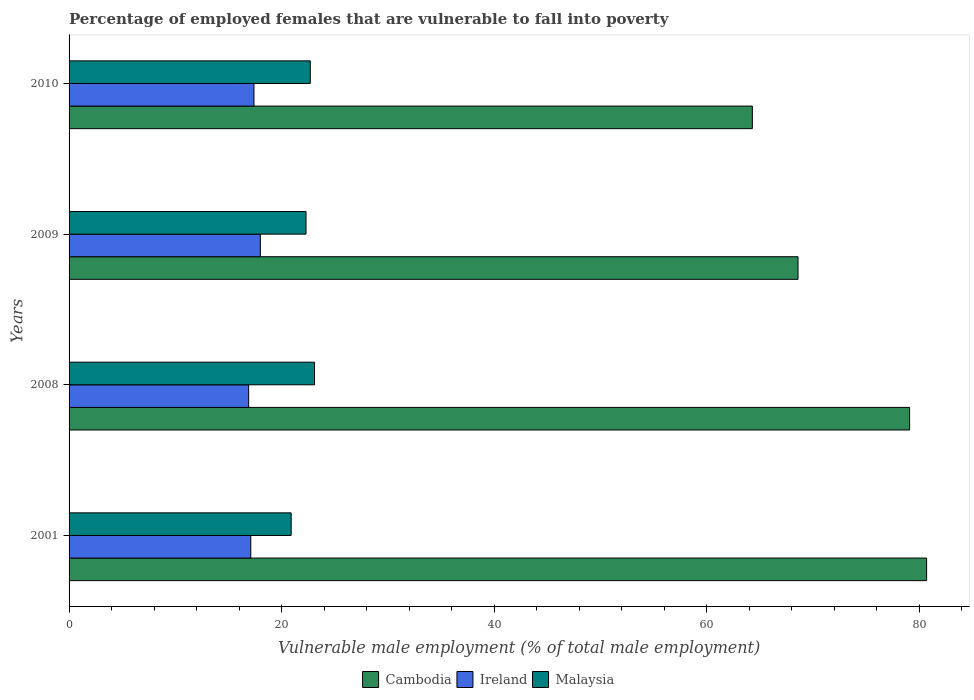Are the number of bars per tick equal to the number of legend labels?
Your answer should be very brief. Yes. Are the number of bars on each tick of the Y-axis equal?
Your answer should be compact. Yes. How many bars are there on the 2nd tick from the top?
Provide a succinct answer. 3. In how many cases, is the number of bars for a given year not equal to the number of legend labels?
Your answer should be compact. 0. What is the percentage of employed females who are vulnerable to fall into poverty in Cambodia in 2008?
Keep it short and to the point. 79.1. Across all years, what is the maximum percentage of employed females who are vulnerable to fall into poverty in Cambodia?
Give a very brief answer. 80.7. Across all years, what is the minimum percentage of employed females who are vulnerable to fall into poverty in Cambodia?
Your answer should be compact. 64.3. In which year was the percentage of employed females who are vulnerable to fall into poverty in Malaysia maximum?
Provide a short and direct response. 2008. In which year was the percentage of employed females who are vulnerable to fall into poverty in Ireland minimum?
Give a very brief answer. 2008. What is the total percentage of employed females who are vulnerable to fall into poverty in Cambodia in the graph?
Offer a terse response. 292.7. What is the difference between the percentage of employed females who are vulnerable to fall into poverty in Cambodia in 2008 and that in 2010?
Ensure brevity in your answer.  14.8. What is the difference between the percentage of employed females who are vulnerable to fall into poverty in Cambodia in 2008 and the percentage of employed females who are vulnerable to fall into poverty in Ireland in 2001?
Offer a terse response. 62. What is the average percentage of employed females who are vulnerable to fall into poverty in Ireland per year?
Provide a short and direct response. 17.35. In the year 2008, what is the difference between the percentage of employed females who are vulnerable to fall into poverty in Ireland and percentage of employed females who are vulnerable to fall into poverty in Malaysia?
Your answer should be very brief. -6.2. What is the ratio of the percentage of employed females who are vulnerable to fall into poverty in Cambodia in 2001 to that in 2010?
Ensure brevity in your answer.  1.26. Is the percentage of employed females who are vulnerable to fall into poverty in Malaysia in 2008 less than that in 2010?
Offer a very short reply. No. Is the difference between the percentage of employed females who are vulnerable to fall into poverty in Ireland in 2001 and 2008 greater than the difference between the percentage of employed females who are vulnerable to fall into poverty in Malaysia in 2001 and 2008?
Make the answer very short. Yes. What is the difference between the highest and the second highest percentage of employed females who are vulnerable to fall into poverty in Cambodia?
Your response must be concise. 1.6. What is the difference between the highest and the lowest percentage of employed females who are vulnerable to fall into poverty in Ireland?
Your answer should be very brief. 1.1. What does the 3rd bar from the top in 2008 represents?
Your response must be concise. Cambodia. What does the 2nd bar from the bottom in 2001 represents?
Your answer should be compact. Ireland. How many bars are there?
Offer a very short reply. 12. Are all the bars in the graph horizontal?
Ensure brevity in your answer.  Yes. How many years are there in the graph?
Keep it short and to the point. 4. Are the values on the major ticks of X-axis written in scientific E-notation?
Your answer should be very brief. No. Does the graph contain grids?
Offer a very short reply. No. Where does the legend appear in the graph?
Your response must be concise. Bottom center. How many legend labels are there?
Offer a very short reply. 3. What is the title of the graph?
Your response must be concise. Percentage of employed females that are vulnerable to fall into poverty. Does "Iceland" appear as one of the legend labels in the graph?
Your response must be concise. No. What is the label or title of the X-axis?
Your answer should be very brief. Vulnerable male employment (% of total male employment). What is the label or title of the Y-axis?
Provide a succinct answer. Years. What is the Vulnerable male employment (% of total male employment) of Cambodia in 2001?
Your answer should be compact. 80.7. What is the Vulnerable male employment (% of total male employment) in Ireland in 2001?
Your answer should be compact. 17.1. What is the Vulnerable male employment (% of total male employment) in Malaysia in 2001?
Your answer should be compact. 20.9. What is the Vulnerable male employment (% of total male employment) of Cambodia in 2008?
Your answer should be very brief. 79.1. What is the Vulnerable male employment (% of total male employment) in Ireland in 2008?
Offer a terse response. 16.9. What is the Vulnerable male employment (% of total male employment) of Malaysia in 2008?
Offer a terse response. 23.1. What is the Vulnerable male employment (% of total male employment) in Cambodia in 2009?
Offer a very short reply. 68.6. What is the Vulnerable male employment (% of total male employment) in Ireland in 2009?
Offer a terse response. 18. What is the Vulnerable male employment (% of total male employment) in Malaysia in 2009?
Offer a very short reply. 22.3. What is the Vulnerable male employment (% of total male employment) in Cambodia in 2010?
Your response must be concise. 64.3. What is the Vulnerable male employment (% of total male employment) in Ireland in 2010?
Offer a terse response. 17.4. What is the Vulnerable male employment (% of total male employment) of Malaysia in 2010?
Make the answer very short. 22.7. Across all years, what is the maximum Vulnerable male employment (% of total male employment) of Cambodia?
Keep it short and to the point. 80.7. Across all years, what is the maximum Vulnerable male employment (% of total male employment) of Ireland?
Your response must be concise. 18. Across all years, what is the maximum Vulnerable male employment (% of total male employment) of Malaysia?
Offer a very short reply. 23.1. Across all years, what is the minimum Vulnerable male employment (% of total male employment) in Cambodia?
Make the answer very short. 64.3. Across all years, what is the minimum Vulnerable male employment (% of total male employment) in Ireland?
Provide a succinct answer. 16.9. Across all years, what is the minimum Vulnerable male employment (% of total male employment) of Malaysia?
Your answer should be very brief. 20.9. What is the total Vulnerable male employment (% of total male employment) of Cambodia in the graph?
Ensure brevity in your answer.  292.7. What is the total Vulnerable male employment (% of total male employment) in Ireland in the graph?
Your response must be concise. 69.4. What is the total Vulnerable male employment (% of total male employment) in Malaysia in the graph?
Offer a very short reply. 89. What is the difference between the Vulnerable male employment (% of total male employment) of Ireland in 2001 and that in 2008?
Provide a short and direct response. 0.2. What is the difference between the Vulnerable male employment (% of total male employment) in Ireland in 2001 and that in 2009?
Provide a short and direct response. -0.9. What is the difference between the Vulnerable male employment (% of total male employment) in Cambodia in 2001 and that in 2010?
Provide a succinct answer. 16.4. What is the difference between the Vulnerable male employment (% of total male employment) in Malaysia in 2001 and that in 2010?
Provide a succinct answer. -1.8. What is the difference between the Vulnerable male employment (% of total male employment) in Cambodia in 2008 and that in 2009?
Your answer should be compact. 10.5. What is the difference between the Vulnerable male employment (% of total male employment) in Malaysia in 2008 and that in 2009?
Make the answer very short. 0.8. What is the difference between the Vulnerable male employment (% of total male employment) in Malaysia in 2008 and that in 2010?
Keep it short and to the point. 0.4. What is the difference between the Vulnerable male employment (% of total male employment) of Cambodia in 2009 and that in 2010?
Keep it short and to the point. 4.3. What is the difference between the Vulnerable male employment (% of total male employment) in Cambodia in 2001 and the Vulnerable male employment (% of total male employment) in Ireland in 2008?
Offer a terse response. 63.8. What is the difference between the Vulnerable male employment (% of total male employment) in Cambodia in 2001 and the Vulnerable male employment (% of total male employment) in Malaysia in 2008?
Offer a terse response. 57.6. What is the difference between the Vulnerable male employment (% of total male employment) in Cambodia in 2001 and the Vulnerable male employment (% of total male employment) in Ireland in 2009?
Give a very brief answer. 62.7. What is the difference between the Vulnerable male employment (% of total male employment) in Cambodia in 2001 and the Vulnerable male employment (% of total male employment) in Malaysia in 2009?
Offer a very short reply. 58.4. What is the difference between the Vulnerable male employment (% of total male employment) in Ireland in 2001 and the Vulnerable male employment (% of total male employment) in Malaysia in 2009?
Provide a short and direct response. -5.2. What is the difference between the Vulnerable male employment (% of total male employment) of Cambodia in 2001 and the Vulnerable male employment (% of total male employment) of Ireland in 2010?
Your response must be concise. 63.3. What is the difference between the Vulnerable male employment (% of total male employment) of Ireland in 2001 and the Vulnerable male employment (% of total male employment) of Malaysia in 2010?
Ensure brevity in your answer.  -5.6. What is the difference between the Vulnerable male employment (% of total male employment) of Cambodia in 2008 and the Vulnerable male employment (% of total male employment) of Ireland in 2009?
Your answer should be compact. 61.1. What is the difference between the Vulnerable male employment (% of total male employment) of Cambodia in 2008 and the Vulnerable male employment (% of total male employment) of Malaysia in 2009?
Your answer should be compact. 56.8. What is the difference between the Vulnerable male employment (% of total male employment) in Ireland in 2008 and the Vulnerable male employment (% of total male employment) in Malaysia in 2009?
Make the answer very short. -5.4. What is the difference between the Vulnerable male employment (% of total male employment) of Cambodia in 2008 and the Vulnerable male employment (% of total male employment) of Ireland in 2010?
Your answer should be very brief. 61.7. What is the difference between the Vulnerable male employment (% of total male employment) in Cambodia in 2008 and the Vulnerable male employment (% of total male employment) in Malaysia in 2010?
Make the answer very short. 56.4. What is the difference between the Vulnerable male employment (% of total male employment) in Cambodia in 2009 and the Vulnerable male employment (% of total male employment) in Ireland in 2010?
Provide a short and direct response. 51.2. What is the difference between the Vulnerable male employment (% of total male employment) of Cambodia in 2009 and the Vulnerable male employment (% of total male employment) of Malaysia in 2010?
Give a very brief answer. 45.9. What is the average Vulnerable male employment (% of total male employment) in Cambodia per year?
Your response must be concise. 73.17. What is the average Vulnerable male employment (% of total male employment) in Ireland per year?
Your response must be concise. 17.35. What is the average Vulnerable male employment (% of total male employment) in Malaysia per year?
Your answer should be very brief. 22.25. In the year 2001, what is the difference between the Vulnerable male employment (% of total male employment) in Cambodia and Vulnerable male employment (% of total male employment) in Ireland?
Ensure brevity in your answer.  63.6. In the year 2001, what is the difference between the Vulnerable male employment (% of total male employment) in Cambodia and Vulnerable male employment (% of total male employment) in Malaysia?
Your response must be concise. 59.8. In the year 2001, what is the difference between the Vulnerable male employment (% of total male employment) of Ireland and Vulnerable male employment (% of total male employment) of Malaysia?
Your answer should be very brief. -3.8. In the year 2008, what is the difference between the Vulnerable male employment (% of total male employment) of Cambodia and Vulnerable male employment (% of total male employment) of Ireland?
Your answer should be very brief. 62.2. In the year 2008, what is the difference between the Vulnerable male employment (% of total male employment) in Cambodia and Vulnerable male employment (% of total male employment) in Malaysia?
Give a very brief answer. 56. In the year 2009, what is the difference between the Vulnerable male employment (% of total male employment) in Cambodia and Vulnerable male employment (% of total male employment) in Ireland?
Provide a succinct answer. 50.6. In the year 2009, what is the difference between the Vulnerable male employment (% of total male employment) in Cambodia and Vulnerable male employment (% of total male employment) in Malaysia?
Your response must be concise. 46.3. In the year 2009, what is the difference between the Vulnerable male employment (% of total male employment) of Ireland and Vulnerable male employment (% of total male employment) of Malaysia?
Provide a succinct answer. -4.3. In the year 2010, what is the difference between the Vulnerable male employment (% of total male employment) in Cambodia and Vulnerable male employment (% of total male employment) in Ireland?
Give a very brief answer. 46.9. In the year 2010, what is the difference between the Vulnerable male employment (% of total male employment) in Cambodia and Vulnerable male employment (% of total male employment) in Malaysia?
Make the answer very short. 41.6. In the year 2010, what is the difference between the Vulnerable male employment (% of total male employment) in Ireland and Vulnerable male employment (% of total male employment) in Malaysia?
Make the answer very short. -5.3. What is the ratio of the Vulnerable male employment (% of total male employment) of Cambodia in 2001 to that in 2008?
Provide a short and direct response. 1.02. What is the ratio of the Vulnerable male employment (% of total male employment) in Ireland in 2001 to that in 2008?
Provide a succinct answer. 1.01. What is the ratio of the Vulnerable male employment (% of total male employment) of Malaysia in 2001 to that in 2008?
Offer a terse response. 0.9. What is the ratio of the Vulnerable male employment (% of total male employment) of Cambodia in 2001 to that in 2009?
Give a very brief answer. 1.18. What is the ratio of the Vulnerable male employment (% of total male employment) of Ireland in 2001 to that in 2009?
Provide a short and direct response. 0.95. What is the ratio of the Vulnerable male employment (% of total male employment) of Malaysia in 2001 to that in 2009?
Make the answer very short. 0.94. What is the ratio of the Vulnerable male employment (% of total male employment) of Cambodia in 2001 to that in 2010?
Make the answer very short. 1.26. What is the ratio of the Vulnerable male employment (% of total male employment) of Ireland in 2001 to that in 2010?
Provide a succinct answer. 0.98. What is the ratio of the Vulnerable male employment (% of total male employment) of Malaysia in 2001 to that in 2010?
Offer a very short reply. 0.92. What is the ratio of the Vulnerable male employment (% of total male employment) of Cambodia in 2008 to that in 2009?
Keep it short and to the point. 1.15. What is the ratio of the Vulnerable male employment (% of total male employment) of Ireland in 2008 to that in 2009?
Keep it short and to the point. 0.94. What is the ratio of the Vulnerable male employment (% of total male employment) of Malaysia in 2008 to that in 2009?
Give a very brief answer. 1.04. What is the ratio of the Vulnerable male employment (% of total male employment) in Cambodia in 2008 to that in 2010?
Provide a short and direct response. 1.23. What is the ratio of the Vulnerable male employment (% of total male employment) of Ireland in 2008 to that in 2010?
Provide a short and direct response. 0.97. What is the ratio of the Vulnerable male employment (% of total male employment) in Malaysia in 2008 to that in 2010?
Offer a very short reply. 1.02. What is the ratio of the Vulnerable male employment (% of total male employment) in Cambodia in 2009 to that in 2010?
Your response must be concise. 1.07. What is the ratio of the Vulnerable male employment (% of total male employment) of Ireland in 2009 to that in 2010?
Offer a very short reply. 1.03. What is the ratio of the Vulnerable male employment (% of total male employment) in Malaysia in 2009 to that in 2010?
Make the answer very short. 0.98. What is the difference between the highest and the second highest Vulnerable male employment (% of total male employment) of Ireland?
Your answer should be compact. 0.6. What is the difference between the highest and the lowest Vulnerable male employment (% of total male employment) in Cambodia?
Ensure brevity in your answer.  16.4. 